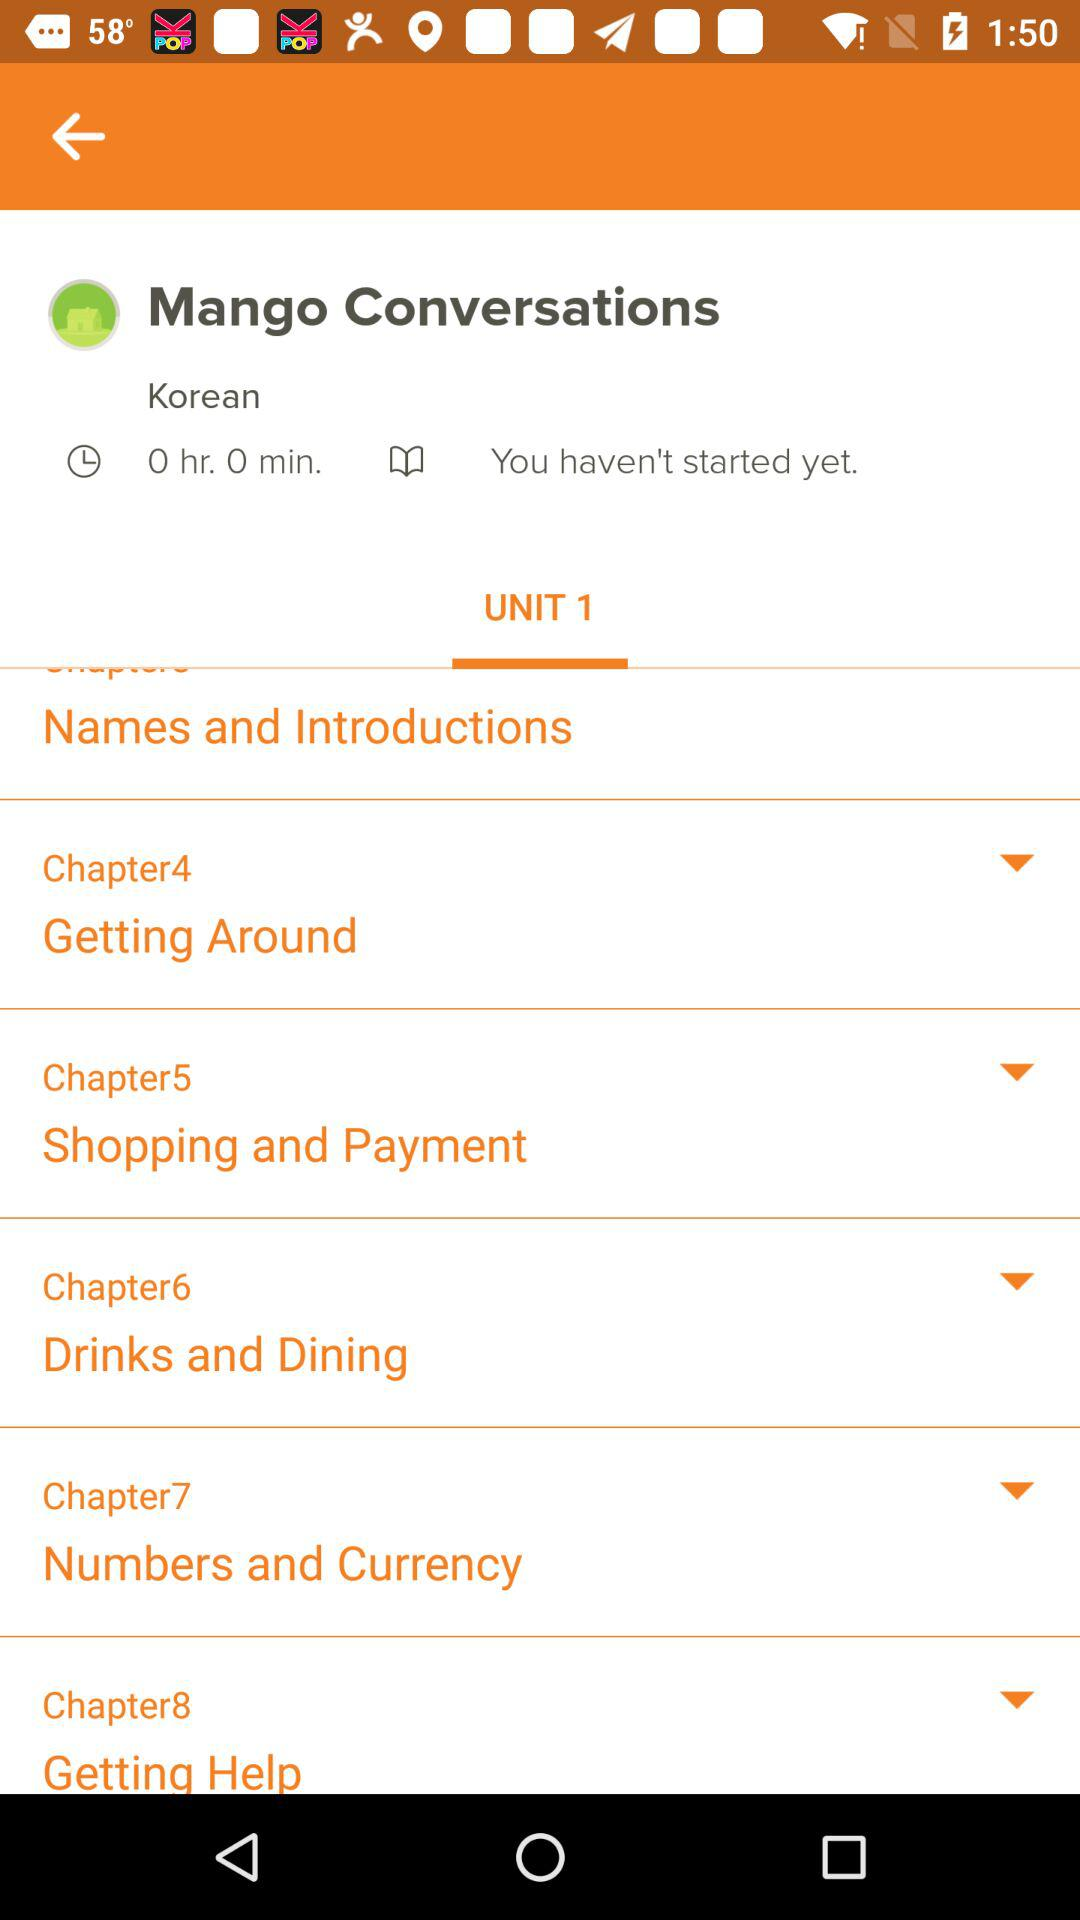What is the name of chapter 4? The name of chapter 4 is "Getting Around". 